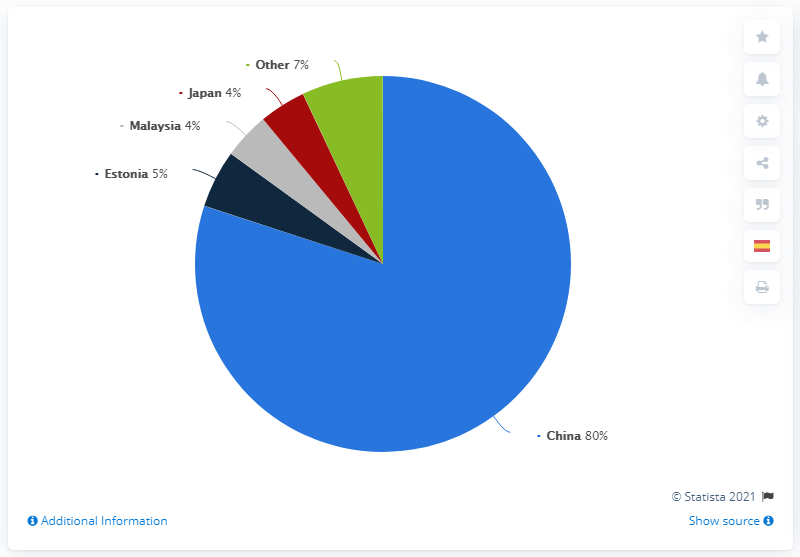Indicate a few pertinent items in this graphic. The distribution of U.S. rare earth imports from Japan is 4%. Eighty percent of rare earth imports into the United States originated from China, according to recent data. The sum of Estonia and Japan in the distribution of U.S. rare earth imports between 2016 and 2019 was 9. 